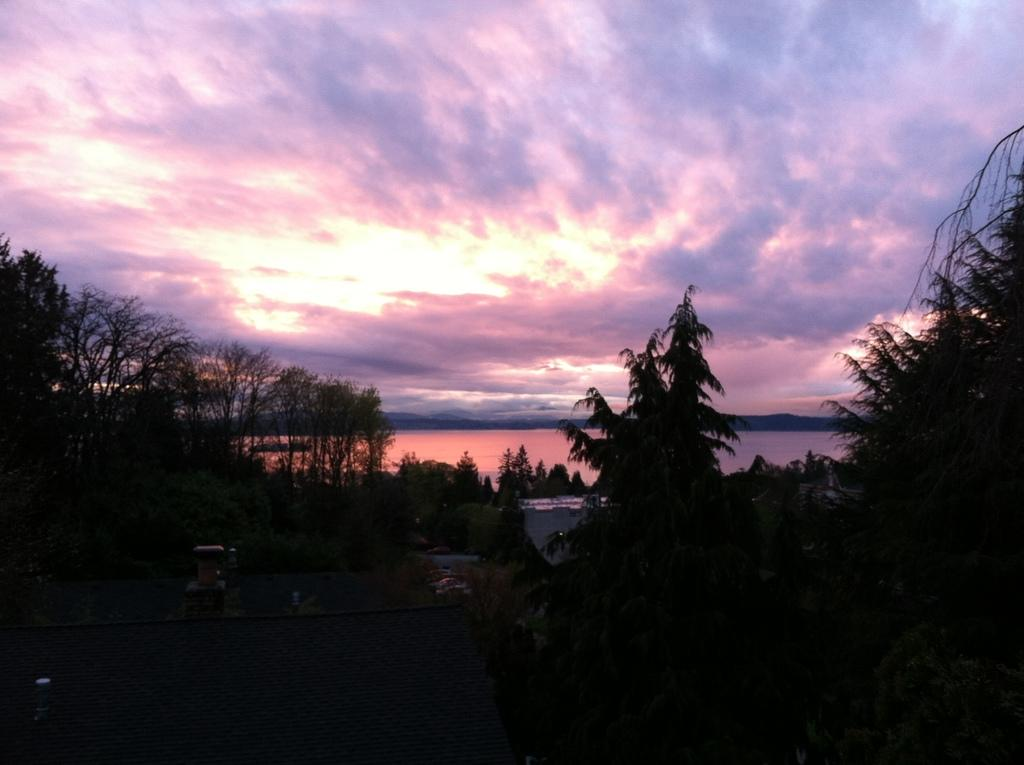What type of natural elements can be seen in the image? There are trees and water visible in the image. What part of the sky is visible in the image? The sky is visible in the image, and clouds are present. Can you describe the overall lighting in the image? The image appears to be slightly dark. What type of music can be heard playing in the background of the image? There is no music present in the image, as it is a still photograph. 